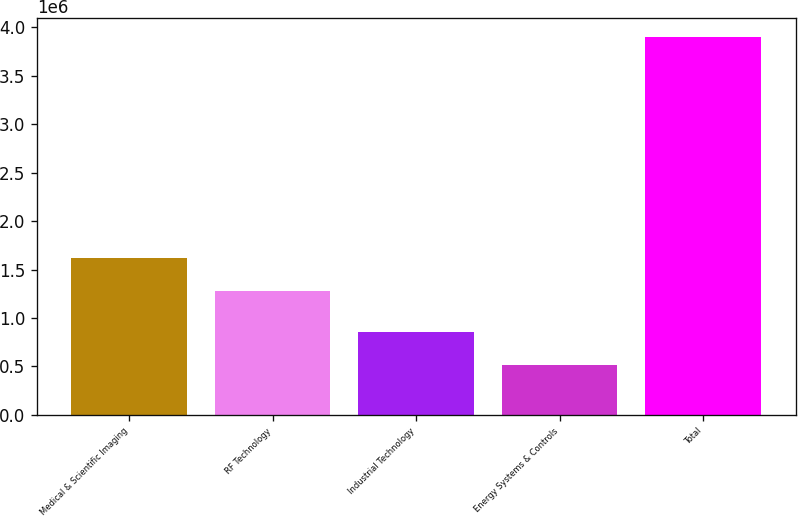<chart> <loc_0><loc_0><loc_500><loc_500><bar_chart><fcel>Medical & Scientific Imaging<fcel>RF Technology<fcel>Industrial Technology<fcel>Energy Systems & Controls<fcel>Total<nl><fcel>1.61643e+06<fcel>1.27825e+06<fcel>852488<fcel>514300<fcel>3.89618e+06<nl></chart> 